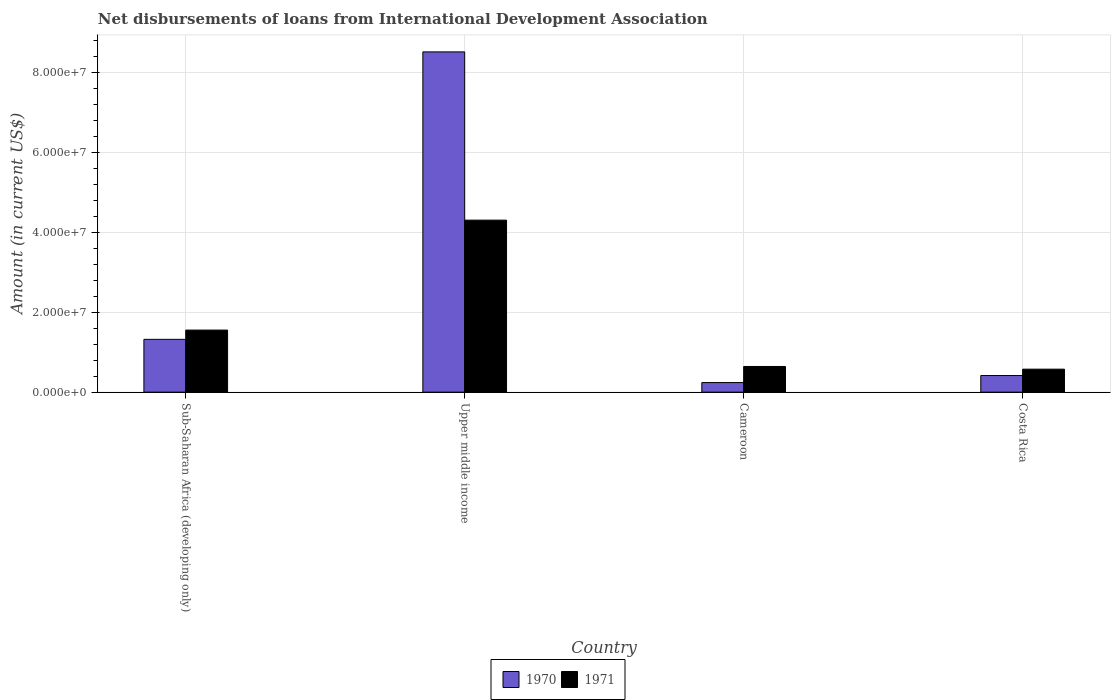How many different coloured bars are there?
Offer a terse response. 2. How many groups of bars are there?
Ensure brevity in your answer.  4. How many bars are there on the 4th tick from the right?
Provide a short and direct response. 2. What is the label of the 4th group of bars from the left?
Your answer should be very brief. Costa Rica. In how many cases, is the number of bars for a given country not equal to the number of legend labels?
Provide a short and direct response. 0. What is the amount of loans disbursed in 1970 in Upper middle income?
Your response must be concise. 8.51e+07. Across all countries, what is the maximum amount of loans disbursed in 1970?
Keep it short and to the point. 8.51e+07. Across all countries, what is the minimum amount of loans disbursed in 1971?
Ensure brevity in your answer.  5.74e+06. In which country was the amount of loans disbursed in 1971 maximum?
Keep it short and to the point. Upper middle income. In which country was the amount of loans disbursed in 1971 minimum?
Provide a succinct answer. Costa Rica. What is the total amount of loans disbursed in 1970 in the graph?
Ensure brevity in your answer.  1.05e+08. What is the difference between the amount of loans disbursed in 1970 in Costa Rica and that in Upper middle income?
Make the answer very short. -8.09e+07. What is the difference between the amount of loans disbursed in 1971 in Upper middle income and the amount of loans disbursed in 1970 in Costa Rica?
Offer a very short reply. 3.88e+07. What is the average amount of loans disbursed in 1971 per country?
Your answer should be compact. 1.77e+07. What is the difference between the amount of loans disbursed of/in 1970 and amount of loans disbursed of/in 1971 in Sub-Saharan Africa (developing only)?
Provide a succinct answer. -2.31e+06. In how many countries, is the amount of loans disbursed in 1970 greater than 24000000 US$?
Make the answer very short. 1. What is the ratio of the amount of loans disbursed in 1970 in Cameroon to that in Costa Rica?
Provide a short and direct response. 0.58. Is the difference between the amount of loans disbursed in 1970 in Cameroon and Sub-Saharan Africa (developing only) greater than the difference between the amount of loans disbursed in 1971 in Cameroon and Sub-Saharan Africa (developing only)?
Keep it short and to the point. No. What is the difference between the highest and the second highest amount of loans disbursed in 1970?
Give a very brief answer. 7.19e+07. What is the difference between the highest and the lowest amount of loans disbursed in 1970?
Offer a terse response. 8.27e+07. In how many countries, is the amount of loans disbursed in 1970 greater than the average amount of loans disbursed in 1970 taken over all countries?
Your response must be concise. 1. Is the sum of the amount of loans disbursed in 1970 in Cameroon and Sub-Saharan Africa (developing only) greater than the maximum amount of loans disbursed in 1971 across all countries?
Your response must be concise. No. What does the 2nd bar from the left in Costa Rica represents?
Give a very brief answer. 1971. How many bars are there?
Give a very brief answer. 8. Are all the bars in the graph horizontal?
Your response must be concise. No. What is the difference between two consecutive major ticks on the Y-axis?
Offer a very short reply. 2.00e+07. Does the graph contain grids?
Ensure brevity in your answer.  Yes. How are the legend labels stacked?
Your answer should be compact. Horizontal. What is the title of the graph?
Offer a very short reply. Net disbursements of loans from International Development Association. What is the label or title of the X-axis?
Ensure brevity in your answer.  Country. What is the label or title of the Y-axis?
Your answer should be compact. Amount (in current US$). What is the Amount (in current US$) in 1970 in Sub-Saharan Africa (developing only)?
Offer a terse response. 1.32e+07. What is the Amount (in current US$) in 1971 in Sub-Saharan Africa (developing only)?
Keep it short and to the point. 1.55e+07. What is the Amount (in current US$) in 1970 in Upper middle income?
Your answer should be very brief. 8.51e+07. What is the Amount (in current US$) in 1971 in Upper middle income?
Ensure brevity in your answer.  4.30e+07. What is the Amount (in current US$) of 1970 in Cameroon?
Keep it short and to the point. 2.40e+06. What is the Amount (in current US$) in 1971 in Cameroon?
Make the answer very short. 6.42e+06. What is the Amount (in current US$) of 1970 in Costa Rica?
Make the answer very short. 4.15e+06. What is the Amount (in current US$) in 1971 in Costa Rica?
Ensure brevity in your answer.  5.74e+06. Across all countries, what is the maximum Amount (in current US$) of 1970?
Provide a succinct answer. 8.51e+07. Across all countries, what is the maximum Amount (in current US$) of 1971?
Give a very brief answer. 4.30e+07. Across all countries, what is the minimum Amount (in current US$) of 1970?
Provide a short and direct response. 2.40e+06. Across all countries, what is the minimum Amount (in current US$) in 1971?
Provide a succinct answer. 5.74e+06. What is the total Amount (in current US$) in 1970 in the graph?
Ensure brevity in your answer.  1.05e+08. What is the total Amount (in current US$) in 1971 in the graph?
Your response must be concise. 7.07e+07. What is the difference between the Amount (in current US$) of 1970 in Sub-Saharan Africa (developing only) and that in Upper middle income?
Ensure brevity in your answer.  -7.19e+07. What is the difference between the Amount (in current US$) in 1971 in Sub-Saharan Africa (developing only) and that in Upper middle income?
Offer a terse response. -2.75e+07. What is the difference between the Amount (in current US$) in 1970 in Sub-Saharan Africa (developing only) and that in Cameroon?
Provide a short and direct response. 1.08e+07. What is the difference between the Amount (in current US$) in 1971 in Sub-Saharan Africa (developing only) and that in Cameroon?
Give a very brief answer. 9.10e+06. What is the difference between the Amount (in current US$) in 1970 in Sub-Saharan Africa (developing only) and that in Costa Rica?
Your response must be concise. 9.05e+06. What is the difference between the Amount (in current US$) of 1971 in Sub-Saharan Africa (developing only) and that in Costa Rica?
Your answer should be very brief. 9.77e+06. What is the difference between the Amount (in current US$) of 1970 in Upper middle income and that in Cameroon?
Keep it short and to the point. 8.27e+07. What is the difference between the Amount (in current US$) in 1971 in Upper middle income and that in Cameroon?
Make the answer very short. 3.66e+07. What is the difference between the Amount (in current US$) in 1970 in Upper middle income and that in Costa Rica?
Give a very brief answer. 8.09e+07. What is the difference between the Amount (in current US$) of 1971 in Upper middle income and that in Costa Rica?
Your answer should be compact. 3.73e+07. What is the difference between the Amount (in current US$) of 1970 in Cameroon and that in Costa Rica?
Your answer should be very brief. -1.76e+06. What is the difference between the Amount (in current US$) of 1971 in Cameroon and that in Costa Rica?
Ensure brevity in your answer.  6.75e+05. What is the difference between the Amount (in current US$) in 1970 in Sub-Saharan Africa (developing only) and the Amount (in current US$) in 1971 in Upper middle income?
Give a very brief answer. -2.98e+07. What is the difference between the Amount (in current US$) of 1970 in Sub-Saharan Africa (developing only) and the Amount (in current US$) of 1971 in Cameroon?
Your answer should be compact. 6.78e+06. What is the difference between the Amount (in current US$) in 1970 in Sub-Saharan Africa (developing only) and the Amount (in current US$) in 1971 in Costa Rica?
Your answer should be compact. 7.46e+06. What is the difference between the Amount (in current US$) of 1970 in Upper middle income and the Amount (in current US$) of 1971 in Cameroon?
Your answer should be very brief. 7.86e+07. What is the difference between the Amount (in current US$) of 1970 in Upper middle income and the Amount (in current US$) of 1971 in Costa Rica?
Your answer should be compact. 7.93e+07. What is the difference between the Amount (in current US$) in 1970 in Cameroon and the Amount (in current US$) in 1971 in Costa Rica?
Provide a succinct answer. -3.35e+06. What is the average Amount (in current US$) of 1970 per country?
Your answer should be compact. 2.62e+07. What is the average Amount (in current US$) in 1971 per country?
Make the answer very short. 1.77e+07. What is the difference between the Amount (in current US$) in 1970 and Amount (in current US$) in 1971 in Sub-Saharan Africa (developing only)?
Your answer should be compact. -2.31e+06. What is the difference between the Amount (in current US$) of 1970 and Amount (in current US$) of 1971 in Upper middle income?
Your answer should be compact. 4.21e+07. What is the difference between the Amount (in current US$) of 1970 and Amount (in current US$) of 1971 in Cameroon?
Offer a very short reply. -4.02e+06. What is the difference between the Amount (in current US$) in 1970 and Amount (in current US$) in 1971 in Costa Rica?
Your response must be concise. -1.59e+06. What is the ratio of the Amount (in current US$) of 1970 in Sub-Saharan Africa (developing only) to that in Upper middle income?
Provide a short and direct response. 0.16. What is the ratio of the Amount (in current US$) of 1971 in Sub-Saharan Africa (developing only) to that in Upper middle income?
Provide a short and direct response. 0.36. What is the ratio of the Amount (in current US$) in 1970 in Sub-Saharan Africa (developing only) to that in Cameroon?
Make the answer very short. 5.51. What is the ratio of the Amount (in current US$) in 1971 in Sub-Saharan Africa (developing only) to that in Cameroon?
Provide a short and direct response. 2.42. What is the ratio of the Amount (in current US$) of 1970 in Sub-Saharan Africa (developing only) to that in Costa Rica?
Keep it short and to the point. 3.18. What is the ratio of the Amount (in current US$) of 1971 in Sub-Saharan Africa (developing only) to that in Costa Rica?
Provide a succinct answer. 2.7. What is the ratio of the Amount (in current US$) in 1970 in Upper middle income to that in Cameroon?
Provide a short and direct response. 35.5. What is the ratio of the Amount (in current US$) in 1971 in Upper middle income to that in Cameroon?
Give a very brief answer. 6.7. What is the ratio of the Amount (in current US$) in 1970 in Upper middle income to that in Costa Rica?
Make the answer very short. 20.48. What is the ratio of the Amount (in current US$) of 1971 in Upper middle income to that in Costa Rica?
Your answer should be compact. 7.49. What is the ratio of the Amount (in current US$) in 1970 in Cameroon to that in Costa Rica?
Give a very brief answer. 0.58. What is the ratio of the Amount (in current US$) in 1971 in Cameroon to that in Costa Rica?
Provide a short and direct response. 1.12. What is the difference between the highest and the second highest Amount (in current US$) of 1970?
Provide a short and direct response. 7.19e+07. What is the difference between the highest and the second highest Amount (in current US$) in 1971?
Your answer should be very brief. 2.75e+07. What is the difference between the highest and the lowest Amount (in current US$) in 1970?
Offer a terse response. 8.27e+07. What is the difference between the highest and the lowest Amount (in current US$) in 1971?
Ensure brevity in your answer.  3.73e+07. 